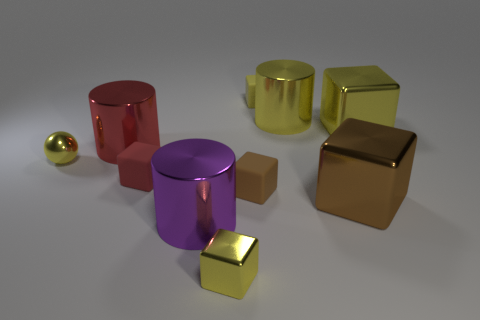Subtract all big purple cylinders. How many cylinders are left? 2 Subtract all purple cylinders. How many yellow cubes are left? 3 Subtract all yellow cubes. How many cubes are left? 3 Subtract 2 cylinders. How many cylinders are left? 1 Subtract all cubes. How many objects are left? 4 Subtract all cyan cubes. Subtract all purple balls. How many cubes are left? 6 Add 2 yellow cylinders. How many yellow cylinders are left? 3 Add 6 green metallic cubes. How many green metallic cubes exist? 6 Subtract 0 green spheres. How many objects are left? 10 Subtract all purple rubber cylinders. Subtract all cylinders. How many objects are left? 7 